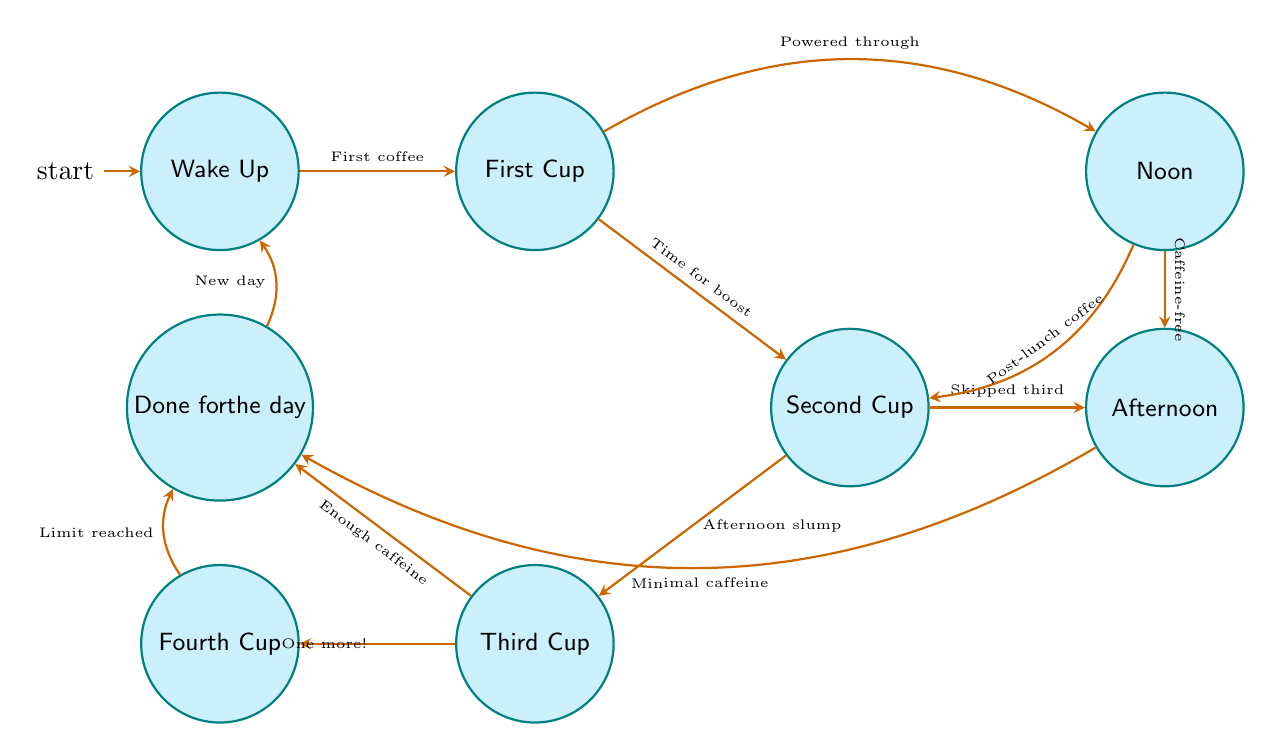What is the initial state of the coffee intake monitoring process? The initial state is "Wake Up," which is where the coffee intake journey begins according to the diagram.
Answer: Wake Up How many total states are represented in the diagram? By counting each distinct state depicted, we find there are seven states: Wake Up, First Cup, Second Cup, Third Cup, Fourth Cup, Noon, Afternoon, and Done for the day. Thus, the total number of states is seven.
Answer: Seven What are the conditions that lead from the First Cup to the Second Cup? The condition to transition from First Cup to Second Cup is "Eyeing the clock, it's time for another boost." This indicates that the user is ready for a second cup of coffee.
Answer: Eyeing the clock, it's time for another boost Which state comes after the Third Cup if enough caffeine has been consumed? If enough caffeine has been consumed in the Third Cup, the next transition leads to the "Done for the day" state, indicating the end of coffee consumption for that day.
Answer: Done for the day What is the transition condition from Noon to the Afternoon state? The condition for transitioning from Noon to the Afternoon state is "Pushed through the day and remained caffeine-free," demonstrating a choice to go without additional coffee after lunch.
Answer: Pushed through the day and remained caffeine-free What happens if one opts for a Fourth Cup after the Third Cup? If one opts for a Fourth Cup after the Third Cup, the state transitions to "Fourth Cup," indicating a decision to indulge in one more cup of coffee despite potential over-caffeination.
Answer: Fourth Cup What state does one enter after deciding to stop drinking coffee for the day? Upon deciding to stop drinking coffee for the day, the state reached is "Done for the day," signifying the conclusion of the caffeine intake cycle.
Answer: Done for the day What triggers the transition from the Fourth Cup back to the Done for the day state? The transition from Fourth Cup back to Done for the day is triggered by the condition "Acknowledged the caffeine limit and decided to stop." This reflects a realization of having consumed enough coffee.
Answer: Acknowledged the caffeine limit and decided to stop What condition leads back to the Wake Up state from Done for the day? The condition leading back to the Wake Up state from Done for the day is "A new day dawns, ready to start the cycle again," marking the restart of the coffee consumption cycle.
Answer: A new day dawns, ready to start the cycle again 